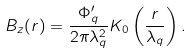<formula> <loc_0><loc_0><loc_500><loc_500>B _ { z } ( r ) = \frac { \Phi _ { q } ^ { \prime } } { 2 \pi \lambda _ { q } ^ { 2 } } K _ { 0 } \left ( \frac { r } { \lambda _ { q } } \right ) .</formula> 